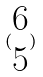<formula> <loc_0><loc_0><loc_500><loc_500>( \begin{matrix} 6 \\ 5 \end{matrix} )</formula> 